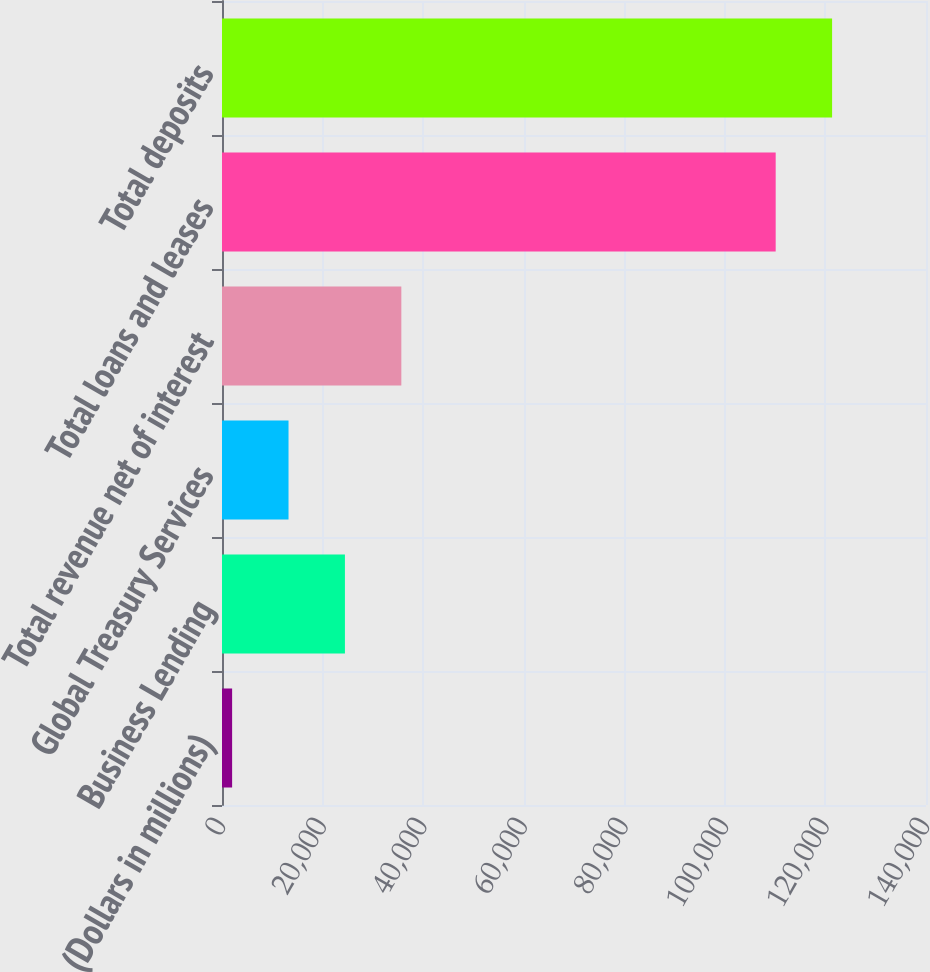Convert chart to OTSL. <chart><loc_0><loc_0><loc_500><loc_500><bar_chart><fcel>(Dollars in millions)<fcel>Business Lending<fcel>Global Treasury Services<fcel>Total revenue net of interest<fcel>Total loans and leases<fcel>Total deposits<nl><fcel>2012<fcel>24446.6<fcel>13229.3<fcel>35663.9<fcel>110109<fcel>121326<nl></chart> 